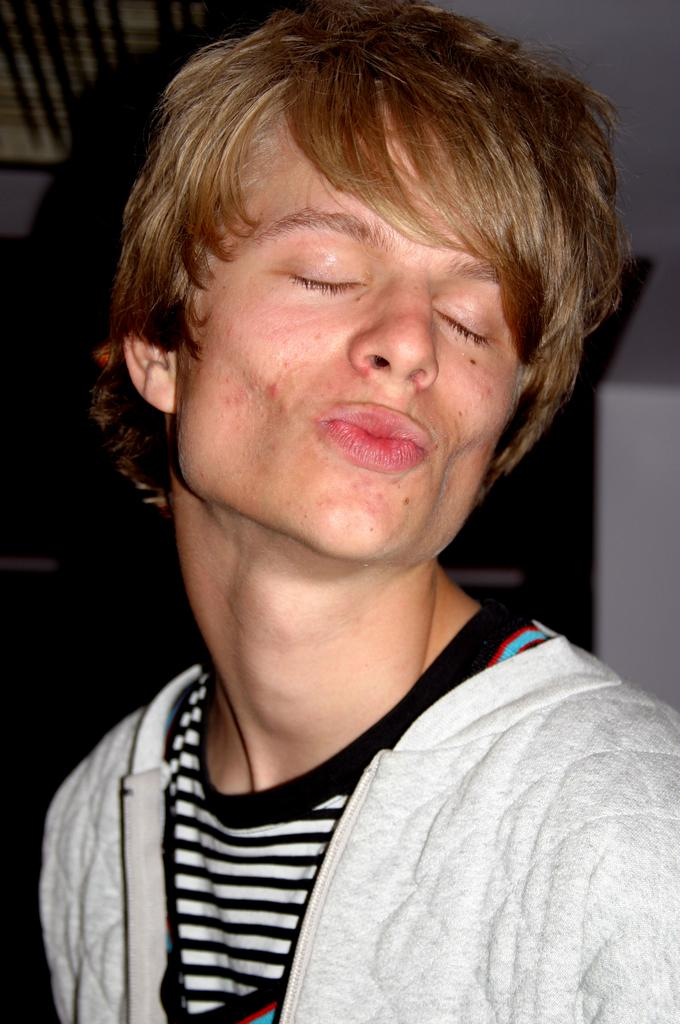What is present in the image? There is a person in the image. What is the person doing in the image? The person has their eyes closed. What can be seen in the background of the image? There are objects in the background of the image. Is the person standing in quicksand in the image? There is no indication of quicksand in the image; it only shows a person with their eyes closed and objects in the background. 